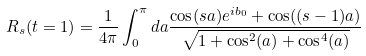<formula> <loc_0><loc_0><loc_500><loc_500>R _ { s } ( t = 1 ) = \frac { 1 } { 4 \pi } \int _ { 0 } ^ { \pi } d a \frac { \cos ( s a ) e ^ { i b _ { 0 } } + \cos ( ( s - 1 ) a ) } { \sqrt { 1 + \cos ^ { 2 } ( a ) + \cos ^ { 4 } ( a ) } }</formula> 